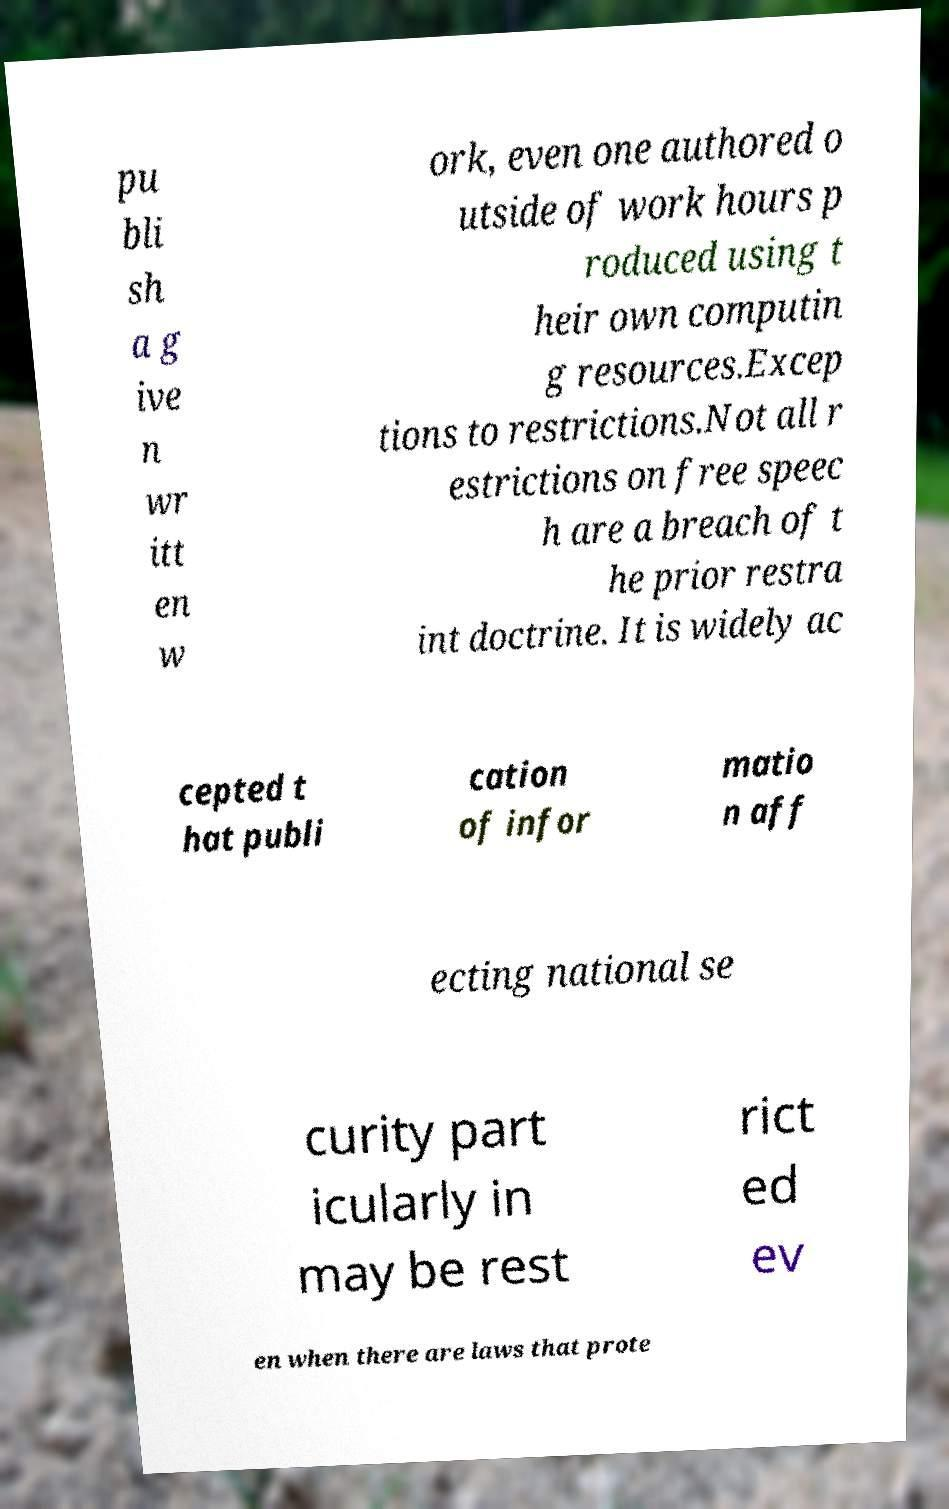Can you read and provide the text displayed in the image?This photo seems to have some interesting text. Can you extract and type it out for me? pu bli sh a g ive n wr itt en w ork, even one authored o utside of work hours p roduced using t heir own computin g resources.Excep tions to restrictions.Not all r estrictions on free speec h are a breach of t he prior restra int doctrine. It is widely ac cepted t hat publi cation of infor matio n aff ecting national se curity part icularly in may be rest rict ed ev en when there are laws that prote 